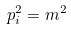<formula> <loc_0><loc_0><loc_500><loc_500>p _ { i } ^ { 2 } = m ^ { 2 }</formula> 